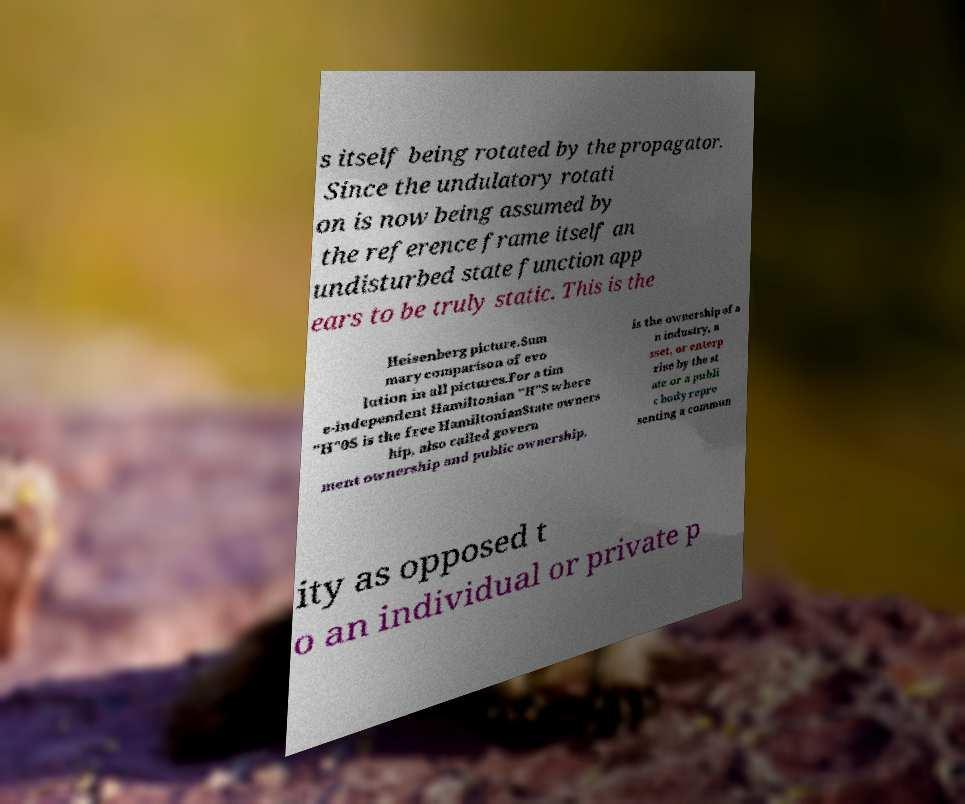Can you read and provide the text displayed in the image?This photo seems to have some interesting text. Can you extract and type it out for me? s itself being rotated by the propagator. Since the undulatory rotati on is now being assumed by the reference frame itself an undisturbed state function app ears to be truly static. This is the Heisenberg picture.Sum mary comparison of evo lution in all pictures.For a tim e-independent Hamiltonian "H"S where "H"0S is the free HamiltonianState owners hip, also called govern ment ownership and public ownership, is the ownership of a n industry, a sset, or enterp rise by the st ate or a publi c body repre senting a commun ity as opposed t o an individual or private p 